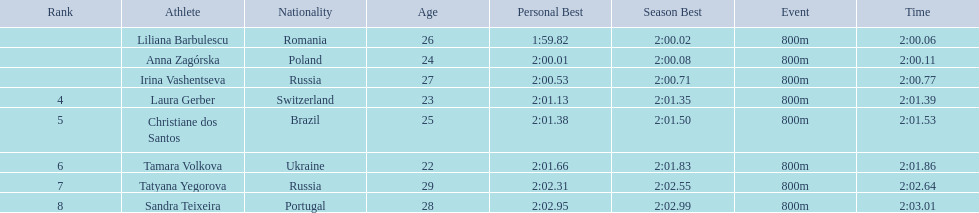What athletes are in the top five for the women's 800 metres? Liliana Barbulescu, Anna Zagórska, Irina Vashentseva, Laura Gerber, Christiane dos Santos. Which athletes are in the top 3? Liliana Barbulescu, Anna Zagórska, Irina Vashentseva. Who is the second place runner in the women's 800 metres? Anna Zagórska. What is the second place runner's time? 2:00.11. 